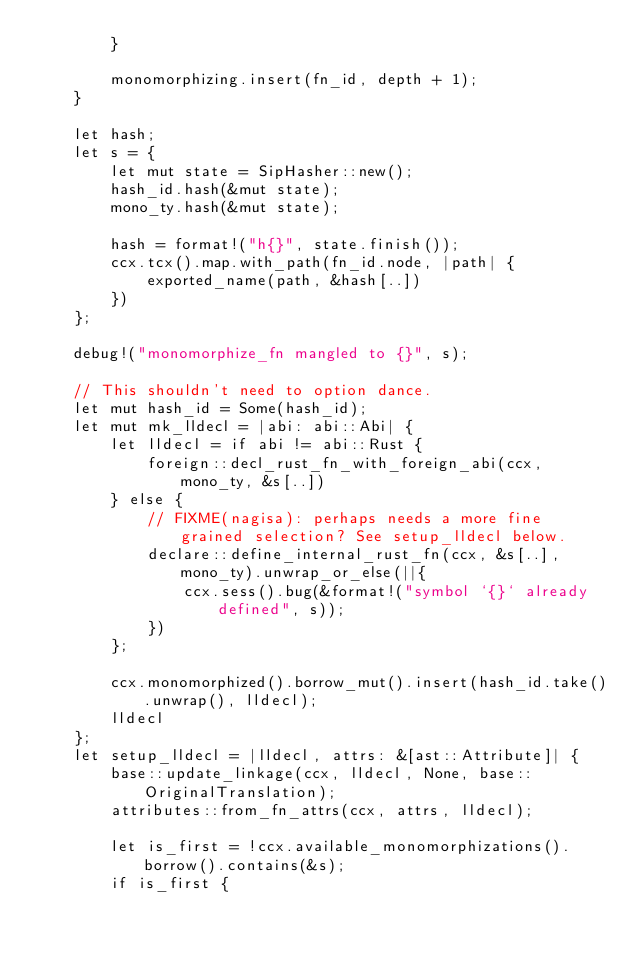Convert code to text. <code><loc_0><loc_0><loc_500><loc_500><_Rust_>        }

        monomorphizing.insert(fn_id, depth + 1);
    }

    let hash;
    let s = {
        let mut state = SipHasher::new();
        hash_id.hash(&mut state);
        mono_ty.hash(&mut state);

        hash = format!("h{}", state.finish());
        ccx.tcx().map.with_path(fn_id.node, |path| {
            exported_name(path, &hash[..])
        })
    };

    debug!("monomorphize_fn mangled to {}", s);

    // This shouldn't need to option dance.
    let mut hash_id = Some(hash_id);
    let mut mk_lldecl = |abi: abi::Abi| {
        let lldecl = if abi != abi::Rust {
            foreign::decl_rust_fn_with_foreign_abi(ccx, mono_ty, &s[..])
        } else {
            // FIXME(nagisa): perhaps needs a more fine grained selection? See setup_lldecl below.
            declare::define_internal_rust_fn(ccx, &s[..], mono_ty).unwrap_or_else(||{
                ccx.sess().bug(&format!("symbol `{}` already defined", s));
            })
        };

        ccx.monomorphized().borrow_mut().insert(hash_id.take().unwrap(), lldecl);
        lldecl
    };
    let setup_lldecl = |lldecl, attrs: &[ast::Attribute]| {
        base::update_linkage(ccx, lldecl, None, base::OriginalTranslation);
        attributes::from_fn_attrs(ccx, attrs, lldecl);

        let is_first = !ccx.available_monomorphizations().borrow().contains(&s);
        if is_first {</code> 